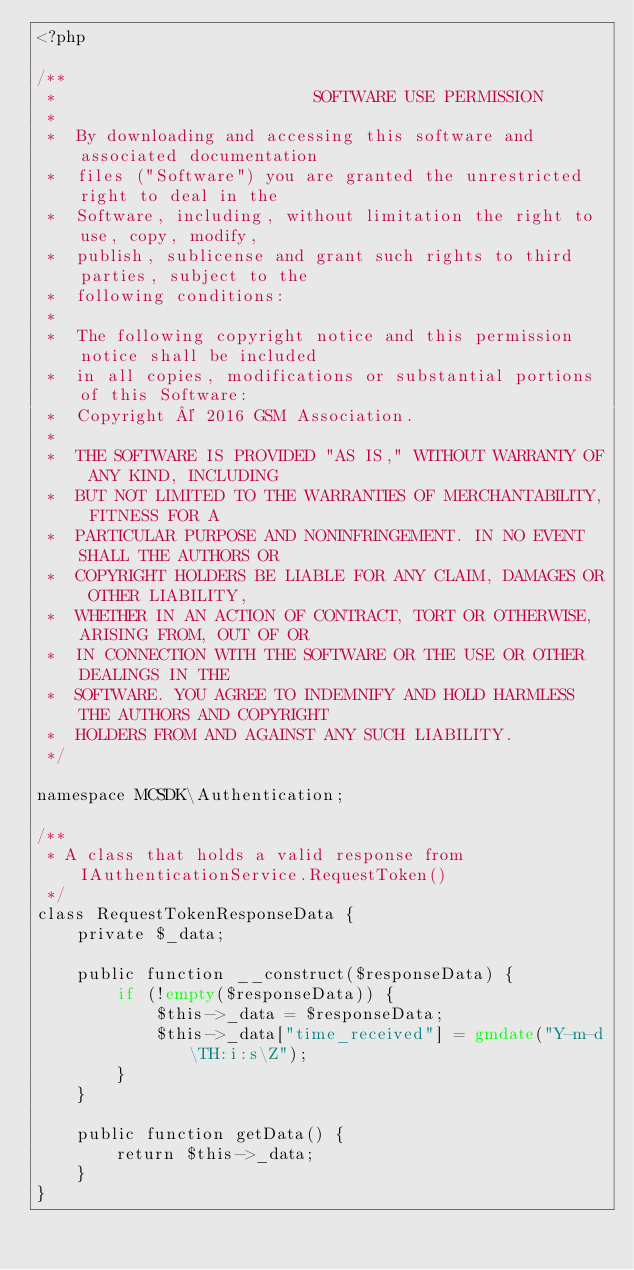Convert code to text. <code><loc_0><loc_0><loc_500><loc_500><_PHP_><?php

/**
 *                          SOFTWARE USE PERMISSION
 *
 *  By downloading and accessing this software and associated documentation
 *  files ("Software") you are granted the unrestricted right to deal in the
 *  Software, including, without limitation the right to use, copy, modify,
 *  publish, sublicense and grant such rights to third parties, subject to the
 *  following conditions:
 *
 *  The following copyright notice and this permission notice shall be included
 *  in all copies, modifications or substantial portions of this Software:
 *  Copyright © 2016 GSM Association.
 *
 *  THE SOFTWARE IS PROVIDED "AS IS," WITHOUT WARRANTY OF ANY KIND, INCLUDING
 *  BUT NOT LIMITED TO THE WARRANTIES OF MERCHANTABILITY, FITNESS FOR A
 *  PARTICULAR PURPOSE AND NONINFRINGEMENT. IN NO EVENT SHALL THE AUTHORS OR
 *  COPYRIGHT HOLDERS BE LIABLE FOR ANY CLAIM, DAMAGES OR OTHER LIABILITY,
 *  WHETHER IN AN ACTION OF CONTRACT, TORT OR OTHERWISE, ARISING FROM, OUT OF OR
 *  IN CONNECTION WITH THE SOFTWARE OR THE USE OR OTHER DEALINGS IN THE
 *  SOFTWARE. YOU AGREE TO INDEMNIFY AND HOLD HARMLESS THE AUTHORS AND COPYRIGHT
 *  HOLDERS FROM AND AGAINST ANY SUCH LIABILITY.
 */

namespace MCSDK\Authentication;

/**
 * A class that holds a valid response from IAuthenticationService.RequestToken()
 */
class RequestTokenResponseData {
    private $_data;

    public function __construct($responseData) {
        if (!empty($responseData)) {
            $this->_data = $responseData;
            $this->_data["time_received"] = gmdate("Y-m-d\TH:i:s\Z");
        }
    }

    public function getData() {
        return $this->_data;
    }
}
</code> 